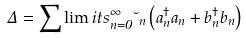Convert formula to latex. <formula><loc_0><loc_0><loc_500><loc_500>\Delta = \sum \lim i t s _ { n = 0 } ^ { \infty } { \lambda _ { n } } \left ( { a _ { n } ^ { \dag } a _ { n } + b _ { n } ^ { \dag } b _ { n } } \right )</formula> 